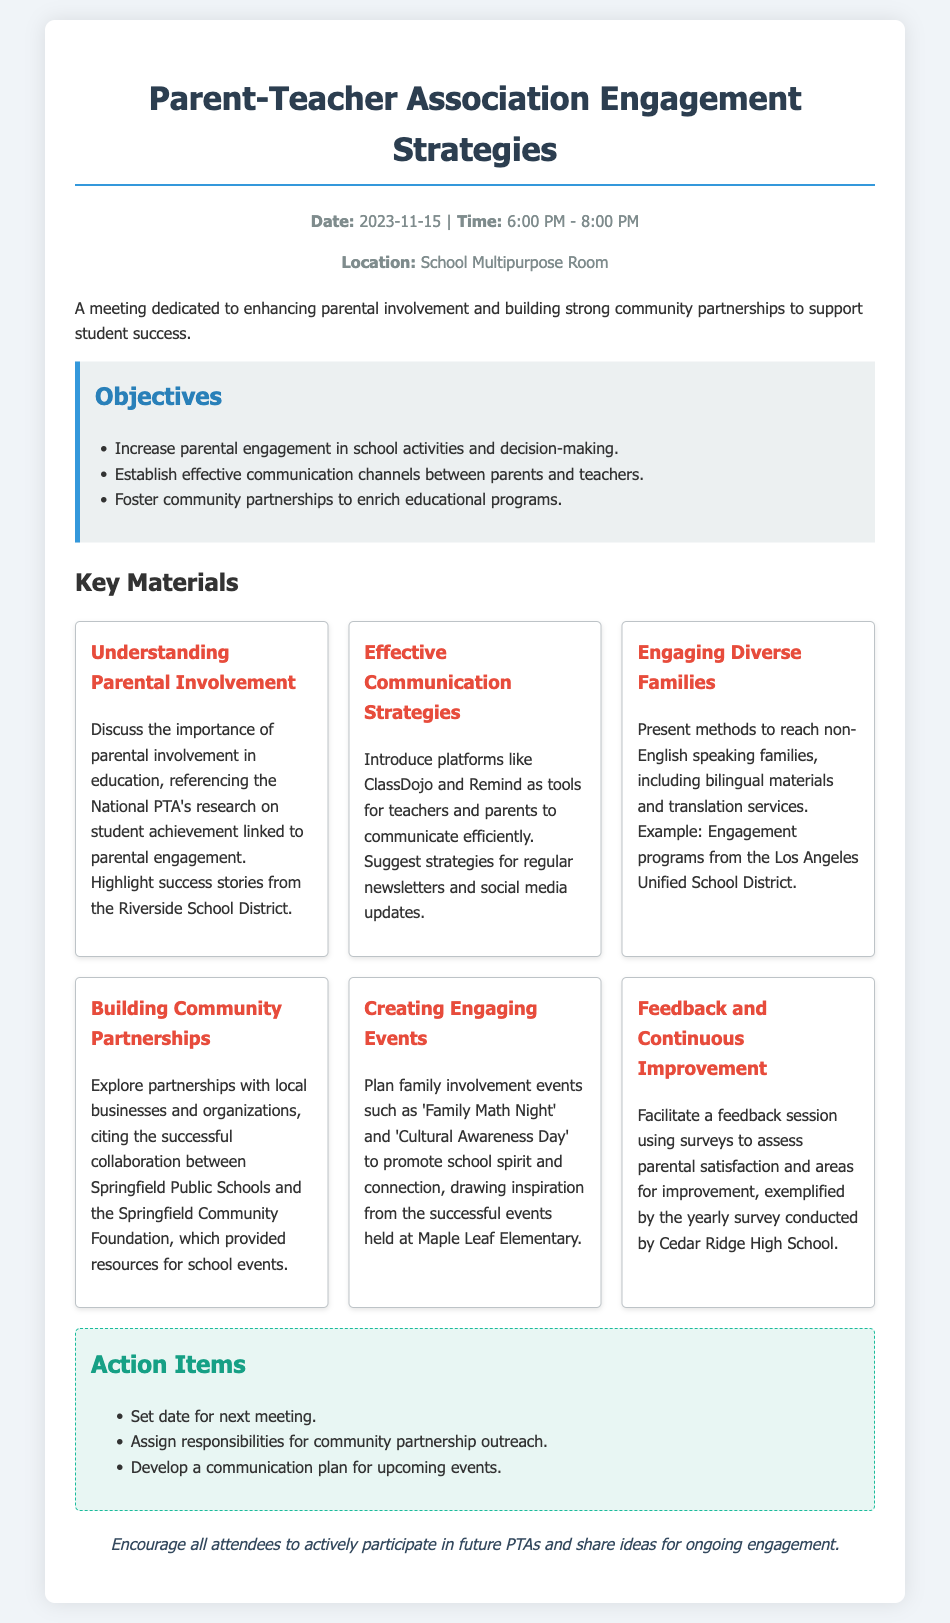What is the date of the meeting? The date of the meeting is specified in the header information section of the document.
Answer: 2023-11-15 What is one of the key materials discussed? Key materials are outlined in the document to highlight specific topics of discussion.
Answer: Understanding Parental Involvement What time does the meeting start? The time of the meeting is detailed in the header information section of the document.
Answer: 6:00 PM Name one objective of the meeting. Objectives are listed to clearly state the purpose of the agenda.
Answer: Increase parental engagement in school activities and decision-making Which communication platform is suggested for teacher-parent interaction? The document mentions various tools for effective communication throughout the event agenda.
Answer: ClassDojo What is one event suggested to promote school spirit? The agenda includes examples of engaging events aimed at increasing parental involvement.
Answer: Family Math Night How will feedback be collected? The document describes methods for assessing parental satisfaction as part of continuous improvement.
Answer: Surveys What is one action item listed in the agenda? Action items provide specific tasks to be accomplished as outcomes from the meeting.
Answer: Set date for next meeting 